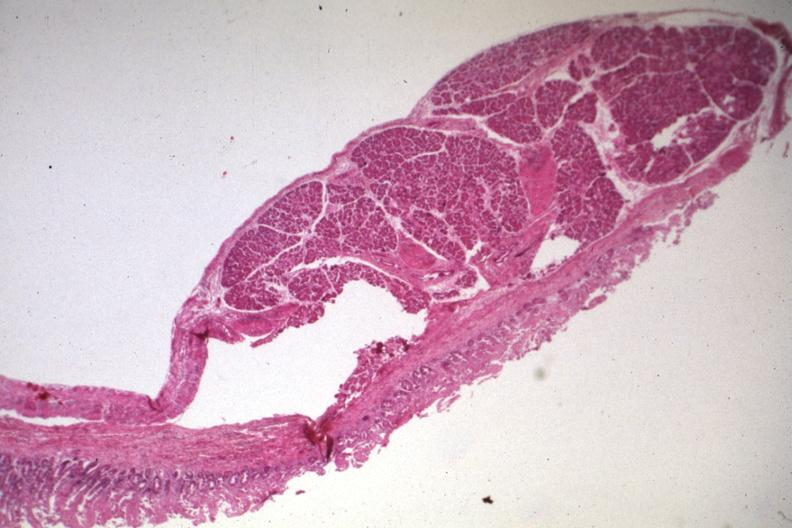what does this image show?
Answer the question using a single word or phrase. Quite good photo of ectopic pancreas 